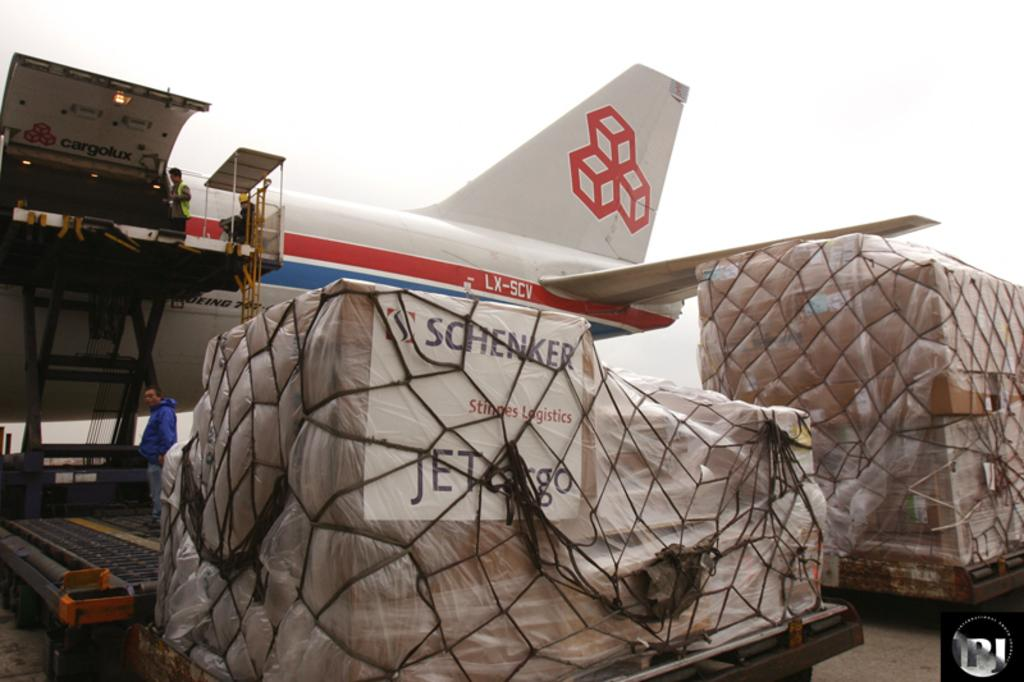Provide a one-sentence caption for the provided image. LX SCV is printed on a jet that is parked near cargo. 